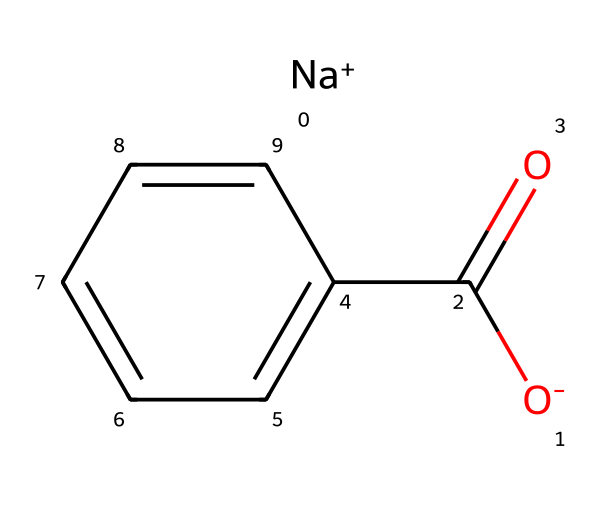What is the common name of the chemical represented by this SMILES? The SMILES structure indicates the presence of a sodium ion and a benzoate anion, which together are known as sodium benzoate.
Answer: sodium benzoate How many carbon atoms are in the chemical structure? By analyzing the structure, there are 7 carbon atoms in total: 1 from the carboxylate group and 6 from the benzene ring.
Answer: 7 What type of bond connects the sodium ion to the benzoate ion? The bond between sodium ion and the benzoate ion is an ionic bond, indicated by the presence of oppositely charged ions in the structure.
Answer: ionic What functional group is present in the sodium benzoate structure? The structure contains a carboxylate functional group, as indicated by the -C(=O)O- part of the SMILES representation.
Answer: carboxylate How many hydrogen atoms are attached to the benzene ring in sodium benzoate? In the structural representation, the benzene ring typically has 5 hydrogen atoms, as one hydrogen is replaced by the carboxylate group formation.
Answer: 5 What role does sodium benzoate play in soft drinks? Sodium benzoate is widely used as a preservative in soft drinks to inhibit the growth of bacteria, yeast, and fungi.
Answer: preservative 